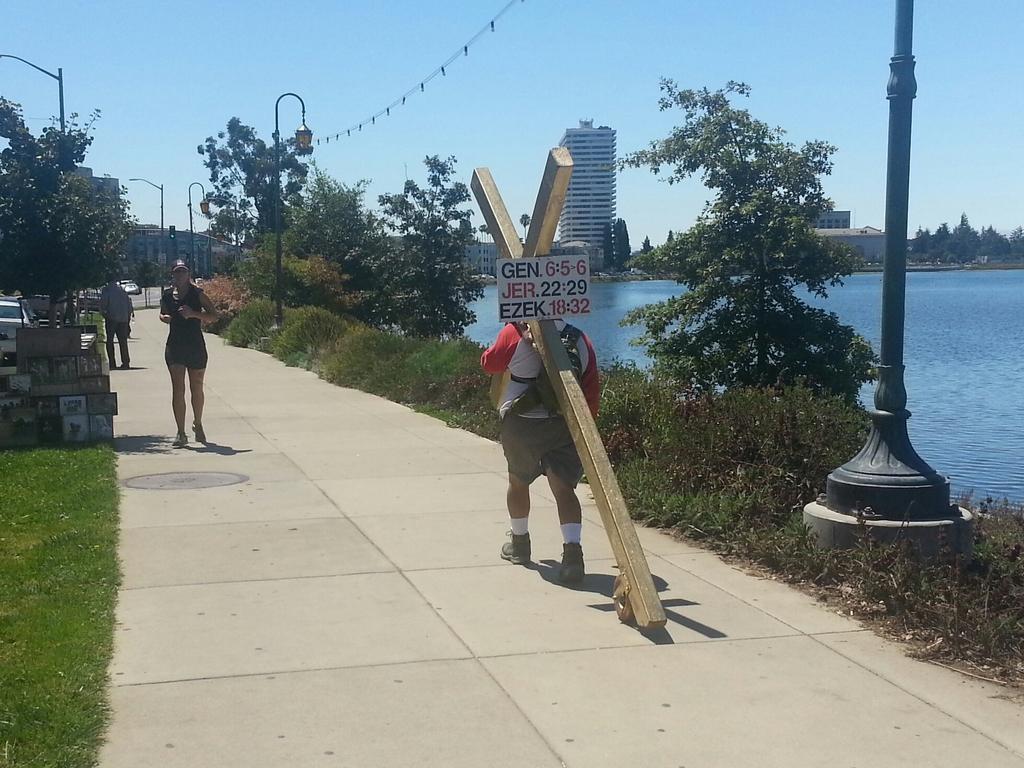Please provide a concise description of this image. In the center of the image there is a person holding the wooden object. In front of him there is a woman running on the road. Behind her there is another person. On the left side of the image there are photo frames. There are cars on the road. There are street lights. On both right and left side of the image there is grass on the surface. On the right side of the image there is a pole. There is water. In the background of the image there are buildings, trees and sky. 